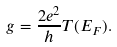Convert formula to latex. <formula><loc_0><loc_0><loc_500><loc_500>g = \frac { 2 e ^ { 2 } } { h } T ( E _ { F } ) .</formula> 